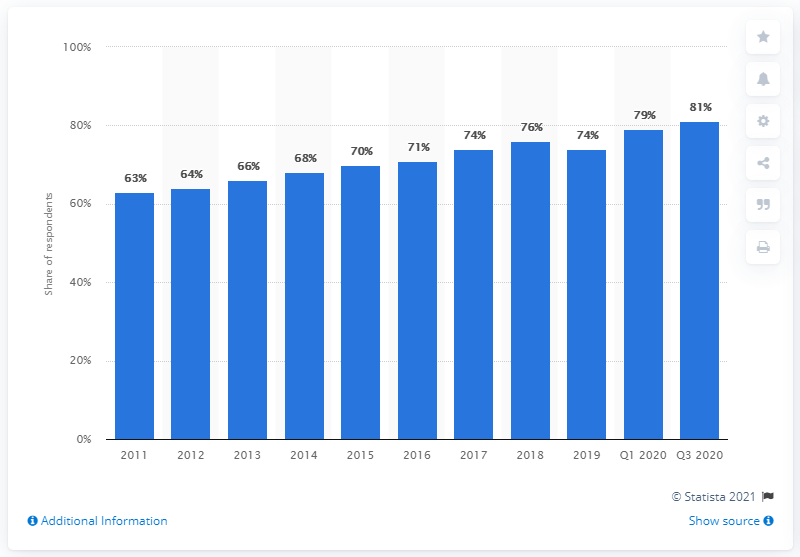Give some essential details in this illustration. In the third quarter of 2020, 81% of Swedes used Facebook. 